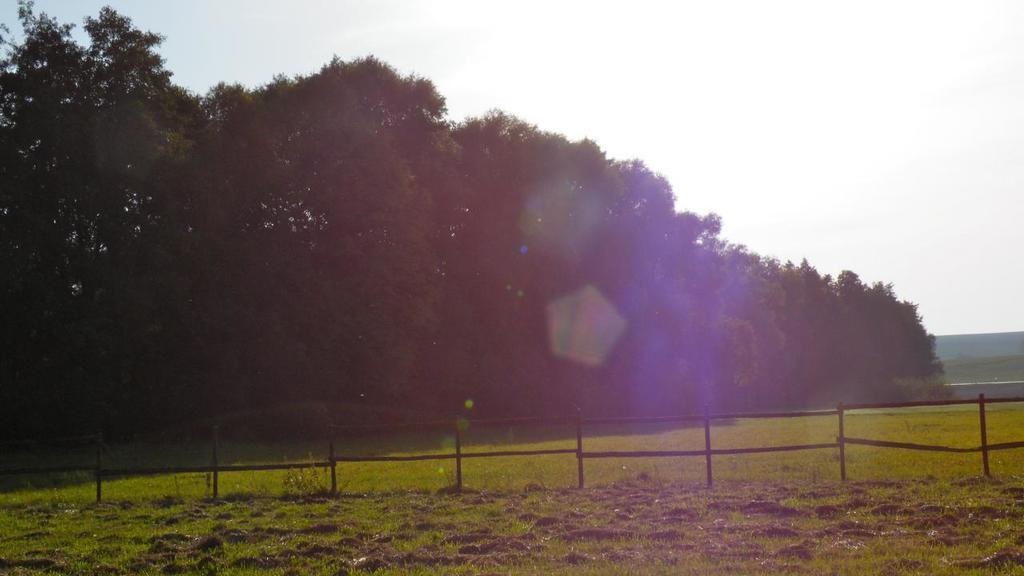Could you give a brief overview of what you see in this image? At the foreground of the image there is grass, fencing and at the background of the image there are some trees and clear sky. 